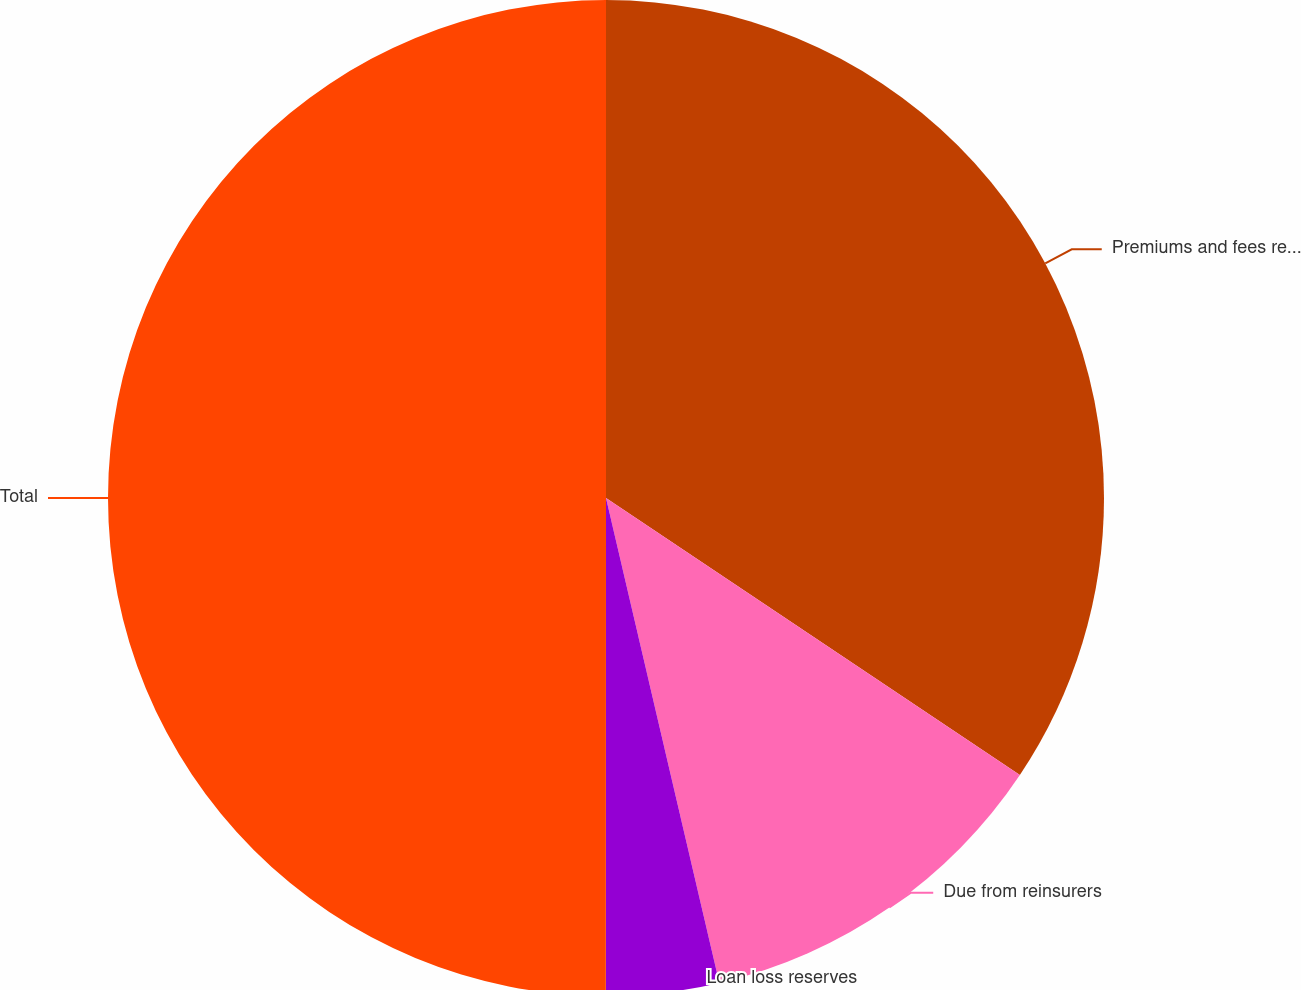<chart> <loc_0><loc_0><loc_500><loc_500><pie_chart><fcel>Premiums and fees receivable<fcel>Due from reinsurers<fcel>Loan loss reserves<fcel>Total<nl><fcel>34.39%<fcel>11.96%<fcel>3.66%<fcel>50.0%<nl></chart> 